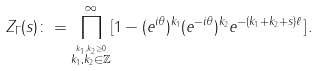Convert formula to latex. <formula><loc_0><loc_0><loc_500><loc_500>Z _ { \Gamma } ( s ) \colon = \prod _ { \stackrel { k _ { 1 } , k _ { 2 } \geq 0 } { k _ { 1 } , k _ { 2 } \in \mathbb { Z } } } ^ { \infty } [ 1 - ( e ^ { i \theta } ) ^ { k _ { 1 } } ( e ^ { - i \theta } ) ^ { k _ { 2 } } e ^ { - ( k _ { 1 } + k _ { 2 } + s ) \ell } ] \, .</formula> 